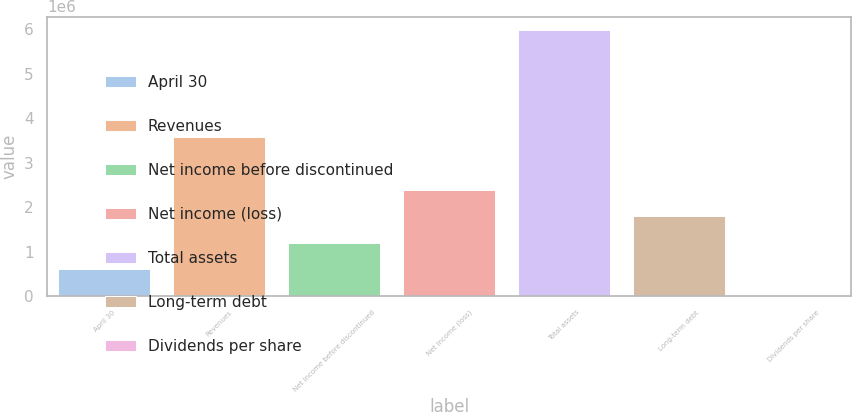Convert chart. <chart><loc_0><loc_0><loc_500><loc_500><bar_chart><fcel>April 30<fcel>Revenues<fcel>Net income before discontinued<fcel>Net income (loss)<fcel>Total assets<fcel>Long-term debt<fcel>Dividends per share<nl><fcel>598914<fcel>3.57475e+06<fcel>1.19783e+06<fcel>2.39565e+06<fcel>5.98914e+06<fcel>1.79674e+06<fcel>0.49<nl></chart> 